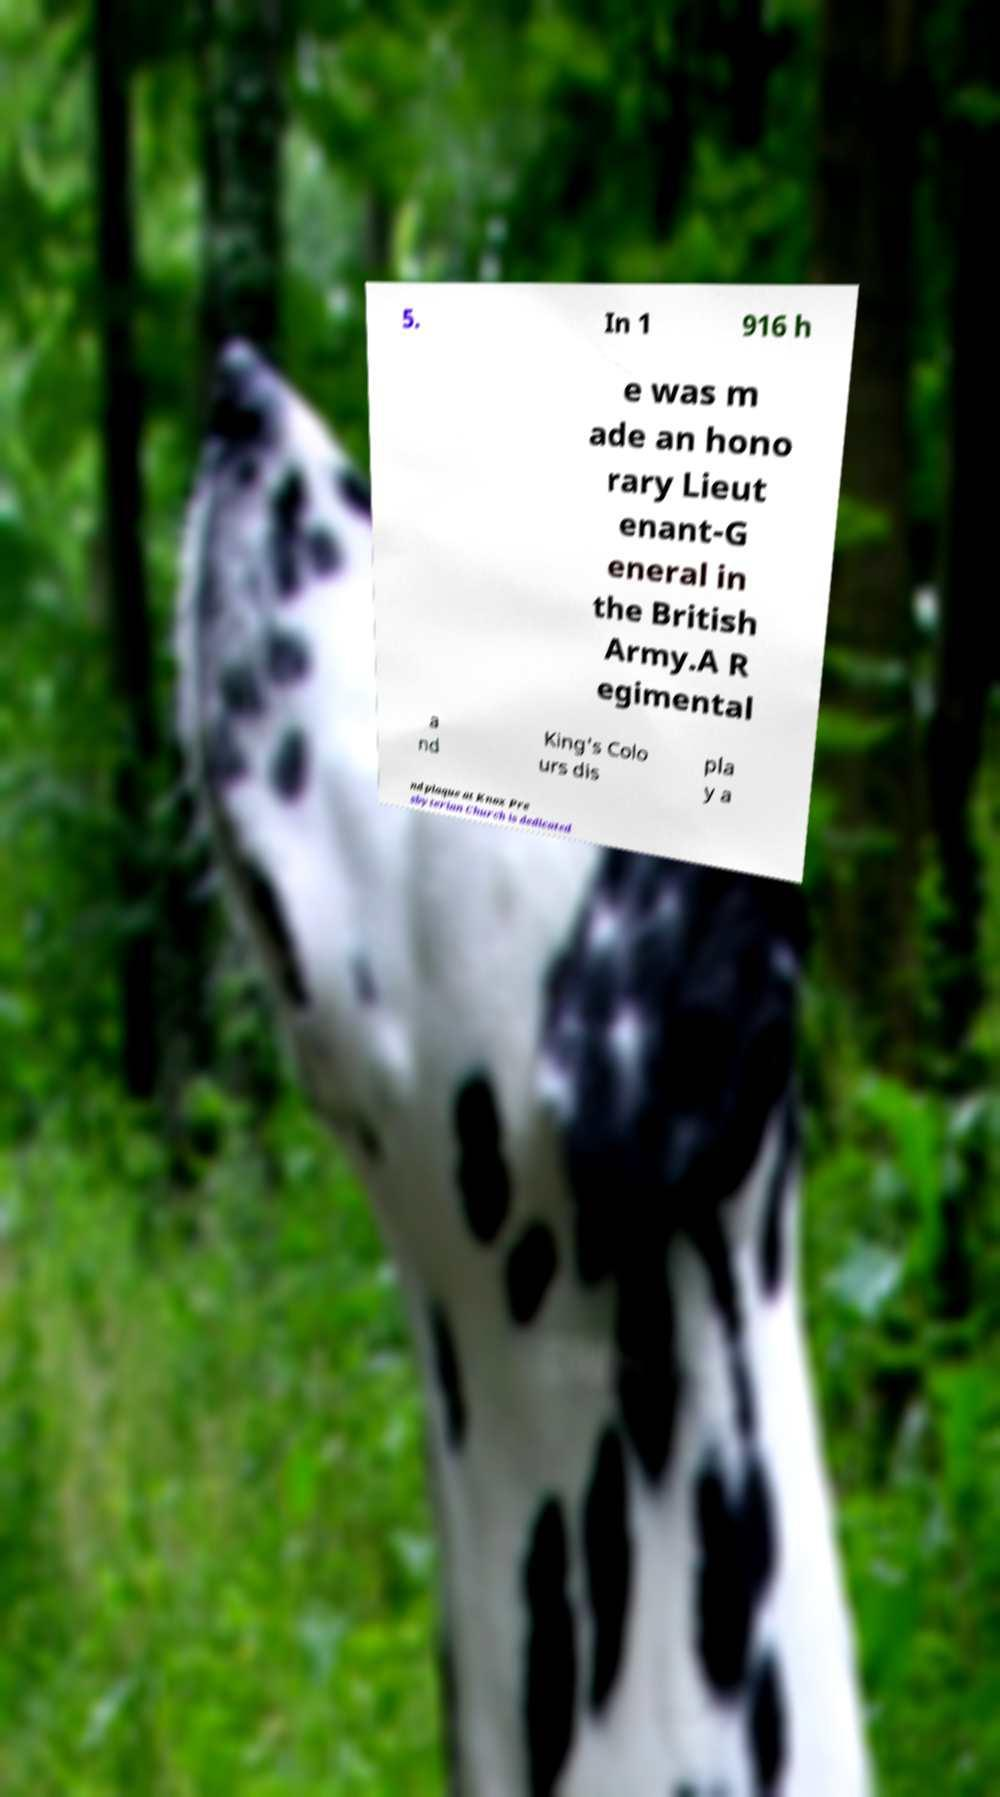Please read and relay the text visible in this image. What does it say? 5. In 1 916 h e was m ade an hono rary Lieut enant-G eneral in the British Army.A R egimental a nd King's Colo urs dis pla y a nd plaque at Knox Pre sbyterian Church is dedicated 